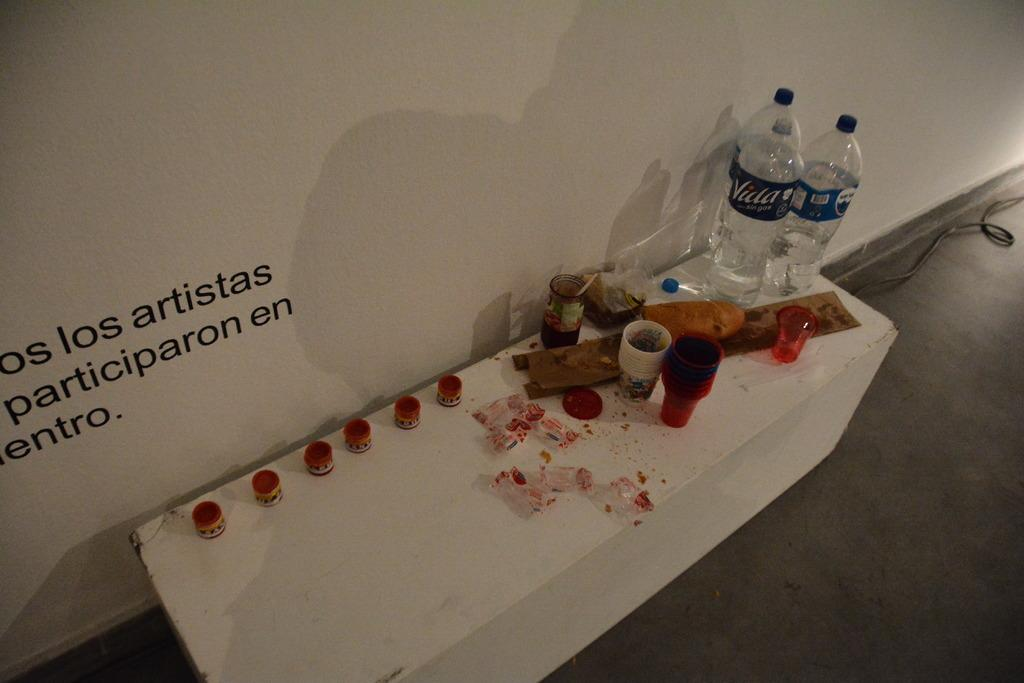<image>
Provide a brief description of the given image. A messy table with food wrappers vida water bottles and other mess. 